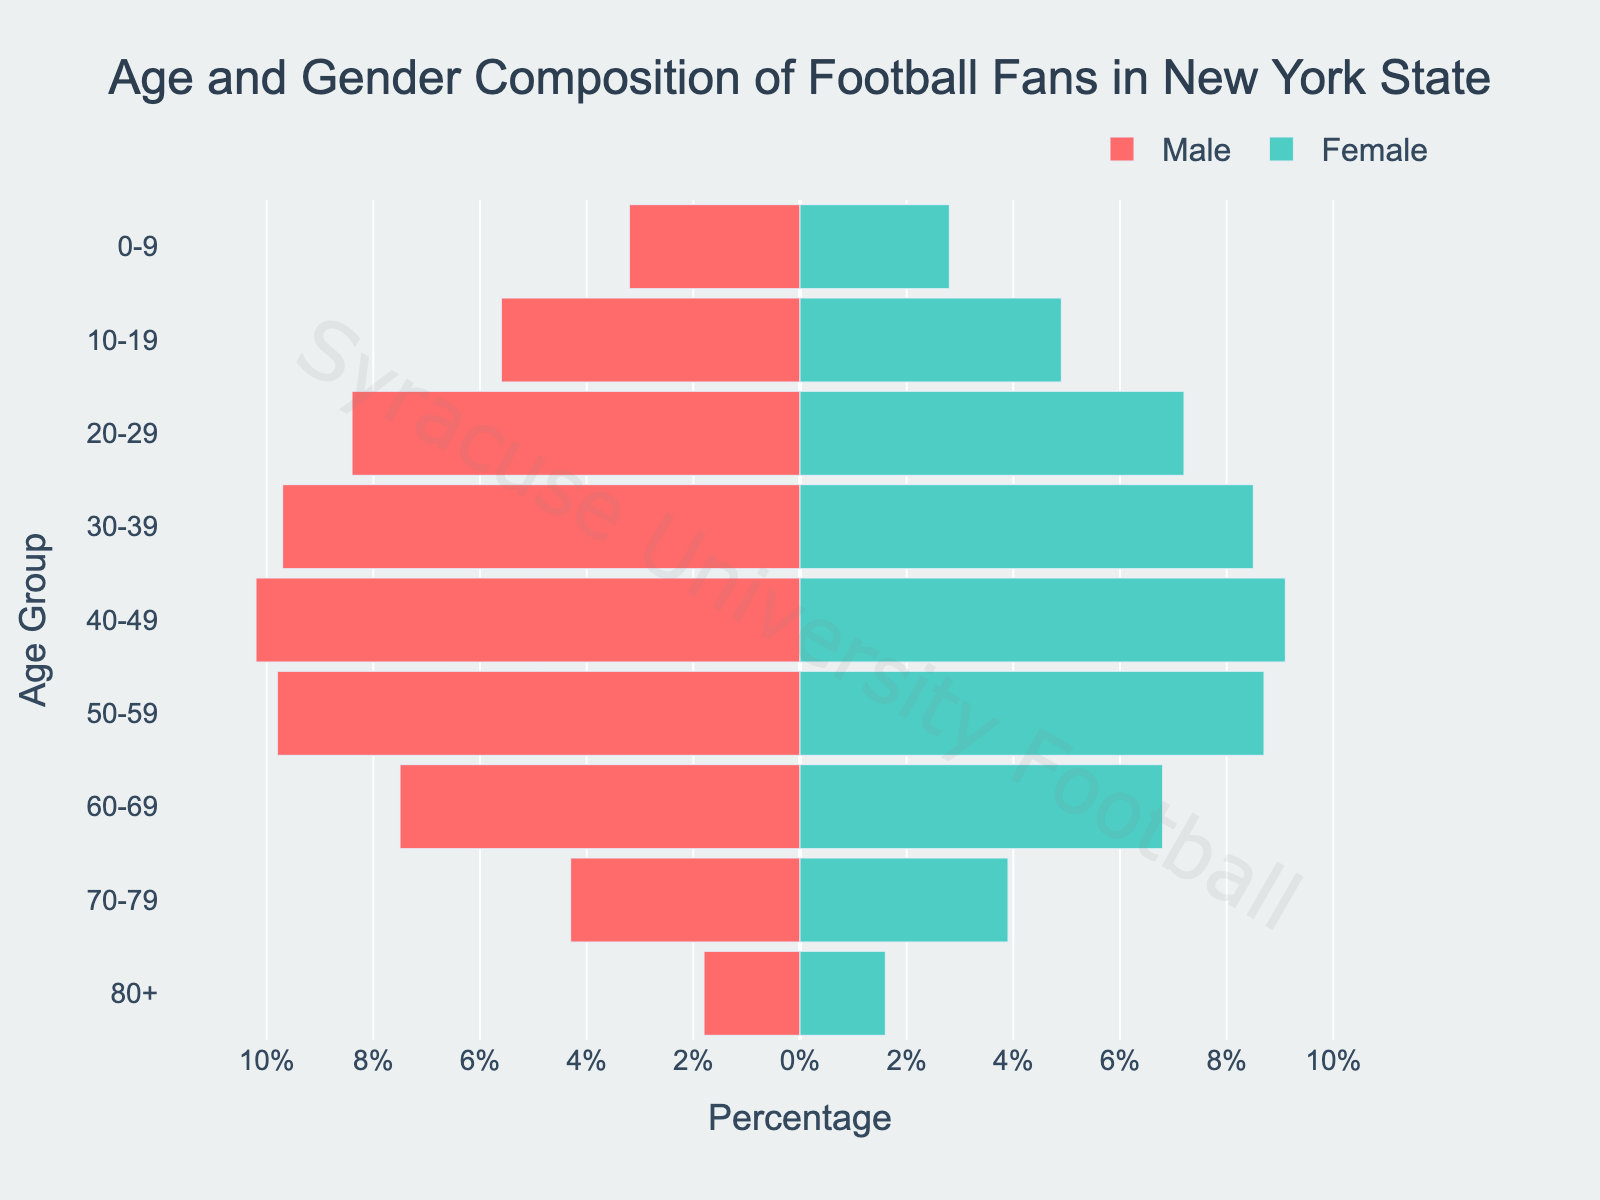What's the title of the figure? The title is located at the top-center of the figure and usually contains a brief description of the chart's content. Looking at the top, you can read the title provided in the figure.
Answer: "Age and Gender Composition of Football Fans in New York State" How do the bars representing males differ from those representing females visually? The figure uses different colors to differentiate males and females. Males are represented by bars in one specific color (typically a shade of red), and females by another color (typically a shade of blue or green). Additionally, male values are negative and appear on the left side, while female values are positive and appear on the right side.
Answer: Males are in red and on the left, females are in green and on the right Which age group has the highest percentage of male football fans? First, locate the male bars, which are on the left side and colored red. Then, find the longest male bar. Check the corresponding age group label on the y-axis for this bar.
Answer: 40-49 What's the total percentage of football fans (male and female) in the 30-39 age group? Sum the male and female percentages for the 30-39 age group. The male percentage is negative and the female percentage is positive, so you add their absolute values together.
Answer: 9.7 + 8.5 = 18.2% Is there any age group where the percentage of female football fans exceeds that of male football fans? Compare the length of the green (female) bars with the red (male) bars for each age group. The female bar needs to exceed the male bar.
Answer: No What is the percentage difference between male and female football fans in the 50-59 age group? Find the male and female percentages for the 50-59 age group and calculate their difference by subtracting the smaller value from the larger one.
Answer: 9.8 - 8.7 = 1.1% Which age group has the lowest percentage of female football fans? Look at the green bars on the figure and find the shortest one. Then note the corresponding age group from the y-axis.
Answer: 80+ Which age group has more football fans, 10-19 or 60-69? Compare the lengths of the bars for both male and female fans in the 10-19 and 60-69 age groups. Sum the percentages for male and female fans in each group to determine the larger value.
Answer: 10-19 (5.6 + 4.9 = 10.5%) How does the percentage of male football fans change from the 20-29 to the 30-39 age group? Look at the lengths of the male bars for the 20-29 and 30-39 age groups, note their percentages, and calculate the difference.
Answer: 9.7 - 8.4 = +1.3% Which gender has a consistently higher percentage of football fans across most age groups? Compare the male and female percentages for each age group, identifying the gender that appears more frequently with higher values.
Answer: Male 